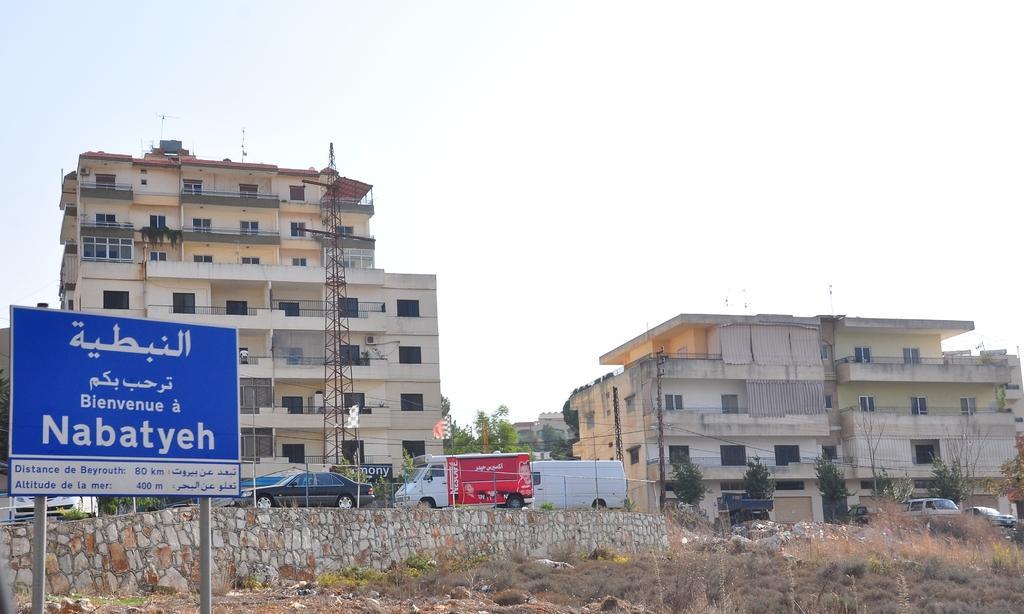Can you describe this image briefly? In this image we can see a few buildings, there are some vehicles, trees, poles, grille, windows and boards with some text, also we can see a tower and the wall, in the background, we can see the sky. 